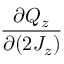<formula> <loc_0><loc_0><loc_500><loc_500>\frac { \partial Q _ { z } } { \partial ( 2 J _ { z } ) }</formula> 